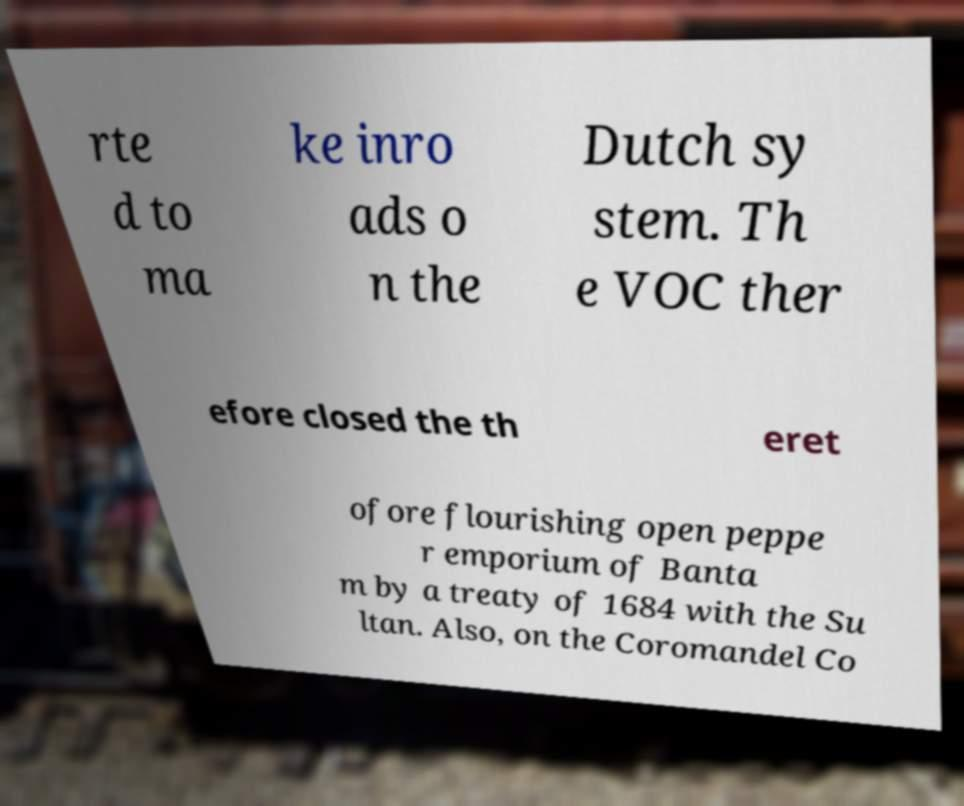Could you assist in decoding the text presented in this image and type it out clearly? rte d to ma ke inro ads o n the Dutch sy stem. Th e VOC ther efore closed the th eret ofore flourishing open peppe r emporium of Banta m by a treaty of 1684 with the Su ltan. Also, on the Coromandel Co 